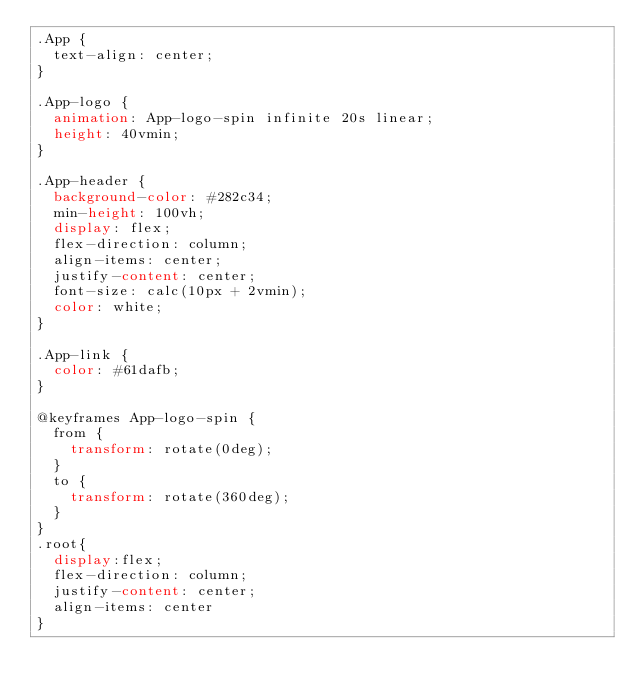Convert code to text. <code><loc_0><loc_0><loc_500><loc_500><_CSS_>.App {
  text-align: center;
}

.App-logo {
  animation: App-logo-spin infinite 20s linear;
  height: 40vmin;
}

.App-header {
  background-color: #282c34;
  min-height: 100vh;
  display: flex;
  flex-direction: column;
  align-items: center;
  justify-content: center;
  font-size: calc(10px + 2vmin);
  color: white;
}

.App-link {
  color: #61dafb;
}

@keyframes App-logo-spin {
  from {
    transform: rotate(0deg);
  }
  to {
    transform: rotate(360deg);
  }
}
.root{
  display:flex;
  flex-direction: column;
  justify-content: center;
  align-items: center
}</code> 